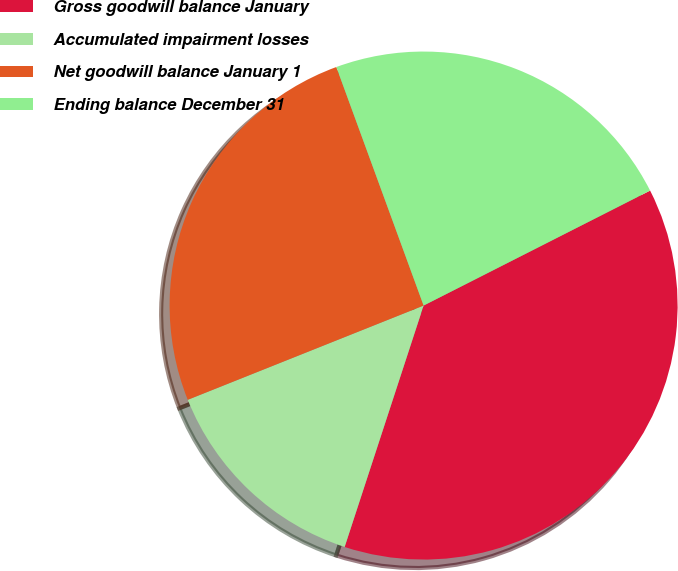<chart> <loc_0><loc_0><loc_500><loc_500><pie_chart><fcel>Gross goodwill balance January<fcel>Accumulated impairment losses<fcel>Net goodwill balance January 1<fcel>Ending balance December 31<nl><fcel>37.51%<fcel>13.92%<fcel>25.47%<fcel>23.11%<nl></chart> 